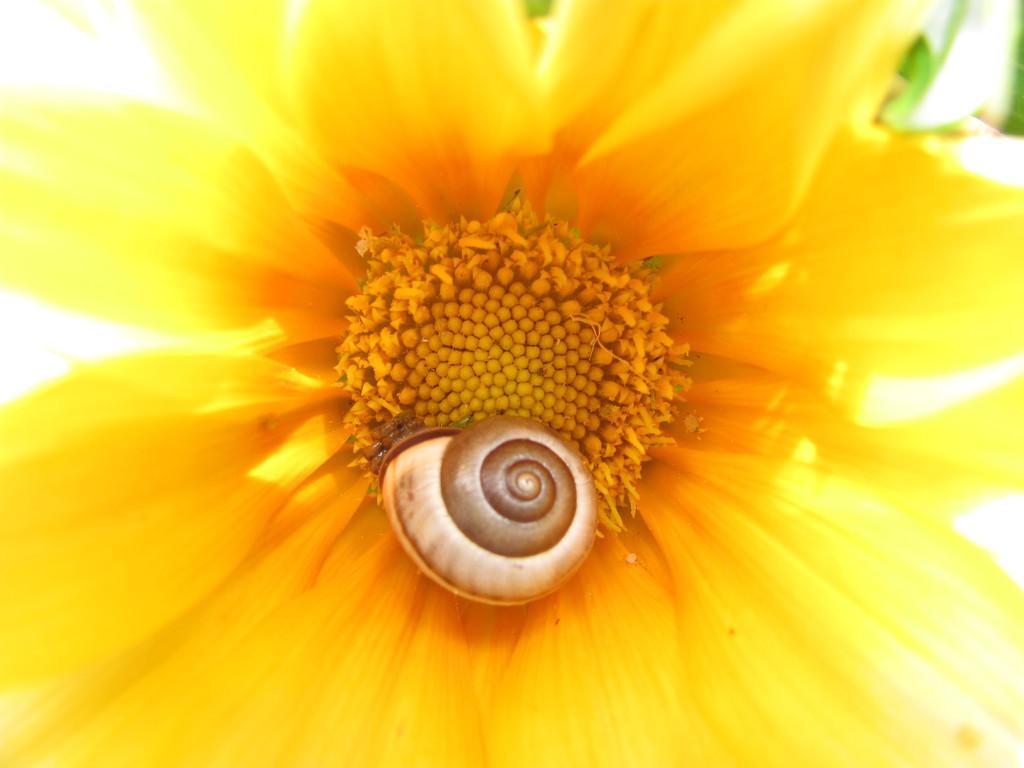Please provide a concise description of this image. In this image we can see a zoom-in picture of a flower, and there is a sea snail shell in the middle of this image. 